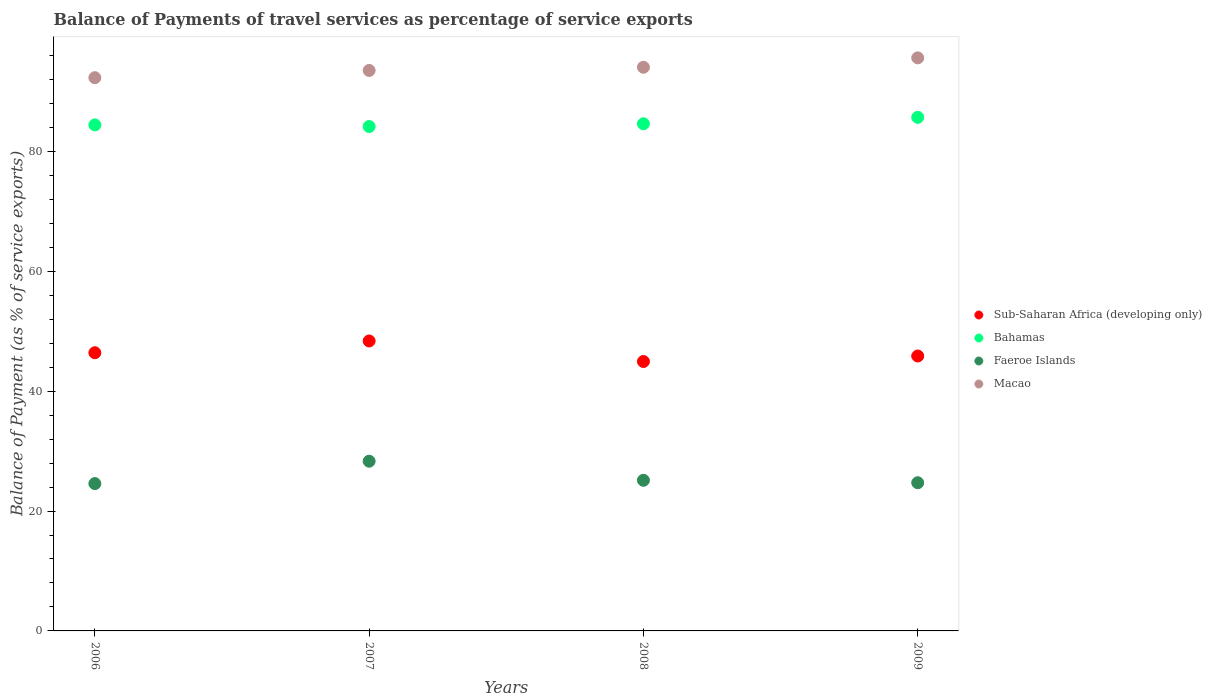Is the number of dotlines equal to the number of legend labels?
Keep it short and to the point. Yes. What is the balance of payments of travel services in Faeroe Islands in 2009?
Provide a succinct answer. 24.72. Across all years, what is the maximum balance of payments of travel services in Bahamas?
Your answer should be very brief. 85.68. Across all years, what is the minimum balance of payments of travel services in Bahamas?
Provide a succinct answer. 84.14. What is the total balance of payments of travel services in Sub-Saharan Africa (developing only) in the graph?
Your answer should be very brief. 185.58. What is the difference between the balance of payments of travel services in Bahamas in 2006 and that in 2007?
Make the answer very short. 0.27. What is the difference between the balance of payments of travel services in Faeroe Islands in 2006 and the balance of payments of travel services in Macao in 2008?
Offer a very short reply. -69.46. What is the average balance of payments of travel services in Macao per year?
Provide a succinct answer. 93.85. In the year 2008, what is the difference between the balance of payments of travel services in Sub-Saharan Africa (developing only) and balance of payments of travel services in Faeroe Islands?
Provide a succinct answer. 19.82. In how many years, is the balance of payments of travel services in Macao greater than 8 %?
Provide a short and direct response. 4. What is the ratio of the balance of payments of travel services in Sub-Saharan Africa (developing only) in 2006 to that in 2007?
Keep it short and to the point. 0.96. Is the difference between the balance of payments of travel services in Sub-Saharan Africa (developing only) in 2006 and 2007 greater than the difference between the balance of payments of travel services in Faeroe Islands in 2006 and 2007?
Make the answer very short. Yes. What is the difference between the highest and the second highest balance of payments of travel services in Sub-Saharan Africa (developing only)?
Provide a short and direct response. 1.97. What is the difference between the highest and the lowest balance of payments of travel services in Faeroe Islands?
Your response must be concise. 3.73. In how many years, is the balance of payments of travel services in Bahamas greater than the average balance of payments of travel services in Bahamas taken over all years?
Offer a very short reply. 1. Is the sum of the balance of payments of travel services in Sub-Saharan Africa (developing only) in 2007 and 2008 greater than the maximum balance of payments of travel services in Faeroe Islands across all years?
Give a very brief answer. Yes. Is it the case that in every year, the sum of the balance of payments of travel services in Macao and balance of payments of travel services in Faeroe Islands  is greater than the balance of payments of travel services in Bahamas?
Make the answer very short. Yes. Does the balance of payments of travel services in Macao monotonically increase over the years?
Give a very brief answer. Yes. Is the balance of payments of travel services in Bahamas strictly greater than the balance of payments of travel services in Sub-Saharan Africa (developing only) over the years?
Keep it short and to the point. Yes. Are the values on the major ticks of Y-axis written in scientific E-notation?
Your answer should be compact. No. Does the graph contain grids?
Offer a terse response. No. How many legend labels are there?
Make the answer very short. 4. How are the legend labels stacked?
Provide a short and direct response. Vertical. What is the title of the graph?
Give a very brief answer. Balance of Payments of travel services as percentage of service exports. Does "Spain" appear as one of the legend labels in the graph?
Your response must be concise. No. What is the label or title of the Y-axis?
Give a very brief answer. Balance of Payment (as % of service exports). What is the Balance of Payment (as % of service exports) in Sub-Saharan Africa (developing only) in 2006?
Provide a short and direct response. 46.4. What is the Balance of Payment (as % of service exports) in Bahamas in 2006?
Ensure brevity in your answer.  84.42. What is the Balance of Payment (as % of service exports) in Faeroe Islands in 2006?
Ensure brevity in your answer.  24.58. What is the Balance of Payment (as % of service exports) of Macao in 2006?
Offer a very short reply. 92.29. What is the Balance of Payment (as % of service exports) of Sub-Saharan Africa (developing only) in 2007?
Offer a terse response. 48.37. What is the Balance of Payment (as % of service exports) of Bahamas in 2007?
Offer a terse response. 84.14. What is the Balance of Payment (as % of service exports) in Faeroe Islands in 2007?
Your answer should be compact. 28.31. What is the Balance of Payment (as % of service exports) in Macao in 2007?
Your answer should be compact. 93.5. What is the Balance of Payment (as % of service exports) in Sub-Saharan Africa (developing only) in 2008?
Your answer should be compact. 44.94. What is the Balance of Payment (as % of service exports) of Bahamas in 2008?
Provide a short and direct response. 84.6. What is the Balance of Payment (as % of service exports) in Faeroe Islands in 2008?
Your answer should be very brief. 25.13. What is the Balance of Payment (as % of service exports) in Macao in 2008?
Your answer should be compact. 94.03. What is the Balance of Payment (as % of service exports) in Sub-Saharan Africa (developing only) in 2009?
Keep it short and to the point. 45.86. What is the Balance of Payment (as % of service exports) in Bahamas in 2009?
Ensure brevity in your answer.  85.68. What is the Balance of Payment (as % of service exports) in Faeroe Islands in 2009?
Your response must be concise. 24.72. What is the Balance of Payment (as % of service exports) of Macao in 2009?
Your response must be concise. 95.6. Across all years, what is the maximum Balance of Payment (as % of service exports) of Sub-Saharan Africa (developing only)?
Your response must be concise. 48.37. Across all years, what is the maximum Balance of Payment (as % of service exports) of Bahamas?
Your answer should be very brief. 85.68. Across all years, what is the maximum Balance of Payment (as % of service exports) in Faeroe Islands?
Offer a terse response. 28.31. Across all years, what is the maximum Balance of Payment (as % of service exports) of Macao?
Give a very brief answer. 95.6. Across all years, what is the minimum Balance of Payment (as % of service exports) in Sub-Saharan Africa (developing only)?
Offer a terse response. 44.94. Across all years, what is the minimum Balance of Payment (as % of service exports) of Bahamas?
Provide a succinct answer. 84.14. Across all years, what is the minimum Balance of Payment (as % of service exports) in Faeroe Islands?
Your answer should be very brief. 24.58. Across all years, what is the minimum Balance of Payment (as % of service exports) in Macao?
Give a very brief answer. 92.29. What is the total Balance of Payment (as % of service exports) of Sub-Saharan Africa (developing only) in the graph?
Your answer should be very brief. 185.58. What is the total Balance of Payment (as % of service exports) in Bahamas in the graph?
Your response must be concise. 338.84. What is the total Balance of Payment (as % of service exports) in Faeroe Islands in the graph?
Provide a succinct answer. 102.74. What is the total Balance of Payment (as % of service exports) in Macao in the graph?
Offer a very short reply. 375.42. What is the difference between the Balance of Payment (as % of service exports) in Sub-Saharan Africa (developing only) in 2006 and that in 2007?
Your response must be concise. -1.97. What is the difference between the Balance of Payment (as % of service exports) of Bahamas in 2006 and that in 2007?
Provide a succinct answer. 0.27. What is the difference between the Balance of Payment (as % of service exports) in Faeroe Islands in 2006 and that in 2007?
Your answer should be very brief. -3.73. What is the difference between the Balance of Payment (as % of service exports) of Macao in 2006 and that in 2007?
Your answer should be very brief. -1.21. What is the difference between the Balance of Payment (as % of service exports) in Sub-Saharan Africa (developing only) in 2006 and that in 2008?
Offer a terse response. 1.46. What is the difference between the Balance of Payment (as % of service exports) in Bahamas in 2006 and that in 2008?
Your answer should be very brief. -0.19. What is the difference between the Balance of Payment (as % of service exports) in Faeroe Islands in 2006 and that in 2008?
Provide a short and direct response. -0.55. What is the difference between the Balance of Payment (as % of service exports) in Macao in 2006 and that in 2008?
Offer a very short reply. -1.74. What is the difference between the Balance of Payment (as % of service exports) in Sub-Saharan Africa (developing only) in 2006 and that in 2009?
Make the answer very short. 0.54. What is the difference between the Balance of Payment (as % of service exports) of Bahamas in 2006 and that in 2009?
Your response must be concise. -1.26. What is the difference between the Balance of Payment (as % of service exports) of Faeroe Islands in 2006 and that in 2009?
Offer a terse response. -0.14. What is the difference between the Balance of Payment (as % of service exports) in Macao in 2006 and that in 2009?
Offer a terse response. -3.31. What is the difference between the Balance of Payment (as % of service exports) of Sub-Saharan Africa (developing only) in 2007 and that in 2008?
Your answer should be very brief. 3.43. What is the difference between the Balance of Payment (as % of service exports) of Bahamas in 2007 and that in 2008?
Offer a terse response. -0.46. What is the difference between the Balance of Payment (as % of service exports) of Faeroe Islands in 2007 and that in 2008?
Your answer should be compact. 3.18. What is the difference between the Balance of Payment (as % of service exports) in Macao in 2007 and that in 2008?
Give a very brief answer. -0.53. What is the difference between the Balance of Payment (as % of service exports) of Sub-Saharan Africa (developing only) in 2007 and that in 2009?
Keep it short and to the point. 2.51. What is the difference between the Balance of Payment (as % of service exports) of Bahamas in 2007 and that in 2009?
Your response must be concise. -1.53. What is the difference between the Balance of Payment (as % of service exports) in Faeroe Islands in 2007 and that in 2009?
Your answer should be very brief. 3.59. What is the difference between the Balance of Payment (as % of service exports) of Macao in 2007 and that in 2009?
Give a very brief answer. -2.1. What is the difference between the Balance of Payment (as % of service exports) of Sub-Saharan Africa (developing only) in 2008 and that in 2009?
Your response must be concise. -0.92. What is the difference between the Balance of Payment (as % of service exports) in Bahamas in 2008 and that in 2009?
Make the answer very short. -1.08. What is the difference between the Balance of Payment (as % of service exports) in Faeroe Islands in 2008 and that in 2009?
Your answer should be very brief. 0.41. What is the difference between the Balance of Payment (as % of service exports) of Macao in 2008 and that in 2009?
Ensure brevity in your answer.  -1.56. What is the difference between the Balance of Payment (as % of service exports) in Sub-Saharan Africa (developing only) in 2006 and the Balance of Payment (as % of service exports) in Bahamas in 2007?
Provide a succinct answer. -37.74. What is the difference between the Balance of Payment (as % of service exports) in Sub-Saharan Africa (developing only) in 2006 and the Balance of Payment (as % of service exports) in Faeroe Islands in 2007?
Offer a very short reply. 18.09. What is the difference between the Balance of Payment (as % of service exports) of Sub-Saharan Africa (developing only) in 2006 and the Balance of Payment (as % of service exports) of Macao in 2007?
Offer a very short reply. -47.1. What is the difference between the Balance of Payment (as % of service exports) of Bahamas in 2006 and the Balance of Payment (as % of service exports) of Faeroe Islands in 2007?
Keep it short and to the point. 56.11. What is the difference between the Balance of Payment (as % of service exports) in Bahamas in 2006 and the Balance of Payment (as % of service exports) in Macao in 2007?
Make the answer very short. -9.08. What is the difference between the Balance of Payment (as % of service exports) of Faeroe Islands in 2006 and the Balance of Payment (as % of service exports) of Macao in 2007?
Your response must be concise. -68.92. What is the difference between the Balance of Payment (as % of service exports) in Sub-Saharan Africa (developing only) in 2006 and the Balance of Payment (as % of service exports) in Bahamas in 2008?
Provide a succinct answer. -38.2. What is the difference between the Balance of Payment (as % of service exports) in Sub-Saharan Africa (developing only) in 2006 and the Balance of Payment (as % of service exports) in Faeroe Islands in 2008?
Make the answer very short. 21.27. What is the difference between the Balance of Payment (as % of service exports) in Sub-Saharan Africa (developing only) in 2006 and the Balance of Payment (as % of service exports) in Macao in 2008?
Ensure brevity in your answer.  -47.63. What is the difference between the Balance of Payment (as % of service exports) in Bahamas in 2006 and the Balance of Payment (as % of service exports) in Faeroe Islands in 2008?
Give a very brief answer. 59.29. What is the difference between the Balance of Payment (as % of service exports) in Bahamas in 2006 and the Balance of Payment (as % of service exports) in Macao in 2008?
Offer a terse response. -9.62. What is the difference between the Balance of Payment (as % of service exports) of Faeroe Islands in 2006 and the Balance of Payment (as % of service exports) of Macao in 2008?
Keep it short and to the point. -69.46. What is the difference between the Balance of Payment (as % of service exports) of Sub-Saharan Africa (developing only) in 2006 and the Balance of Payment (as % of service exports) of Bahamas in 2009?
Offer a very short reply. -39.28. What is the difference between the Balance of Payment (as % of service exports) in Sub-Saharan Africa (developing only) in 2006 and the Balance of Payment (as % of service exports) in Faeroe Islands in 2009?
Offer a terse response. 21.68. What is the difference between the Balance of Payment (as % of service exports) in Sub-Saharan Africa (developing only) in 2006 and the Balance of Payment (as % of service exports) in Macao in 2009?
Provide a succinct answer. -49.19. What is the difference between the Balance of Payment (as % of service exports) of Bahamas in 2006 and the Balance of Payment (as % of service exports) of Faeroe Islands in 2009?
Keep it short and to the point. 59.7. What is the difference between the Balance of Payment (as % of service exports) in Bahamas in 2006 and the Balance of Payment (as % of service exports) in Macao in 2009?
Give a very brief answer. -11.18. What is the difference between the Balance of Payment (as % of service exports) of Faeroe Islands in 2006 and the Balance of Payment (as % of service exports) of Macao in 2009?
Make the answer very short. -71.02. What is the difference between the Balance of Payment (as % of service exports) in Sub-Saharan Africa (developing only) in 2007 and the Balance of Payment (as % of service exports) in Bahamas in 2008?
Provide a short and direct response. -36.23. What is the difference between the Balance of Payment (as % of service exports) in Sub-Saharan Africa (developing only) in 2007 and the Balance of Payment (as % of service exports) in Faeroe Islands in 2008?
Offer a very short reply. 23.24. What is the difference between the Balance of Payment (as % of service exports) of Sub-Saharan Africa (developing only) in 2007 and the Balance of Payment (as % of service exports) of Macao in 2008?
Make the answer very short. -45.66. What is the difference between the Balance of Payment (as % of service exports) in Bahamas in 2007 and the Balance of Payment (as % of service exports) in Faeroe Islands in 2008?
Provide a short and direct response. 59.02. What is the difference between the Balance of Payment (as % of service exports) of Bahamas in 2007 and the Balance of Payment (as % of service exports) of Macao in 2008?
Give a very brief answer. -9.89. What is the difference between the Balance of Payment (as % of service exports) in Faeroe Islands in 2007 and the Balance of Payment (as % of service exports) in Macao in 2008?
Your answer should be very brief. -65.72. What is the difference between the Balance of Payment (as % of service exports) in Sub-Saharan Africa (developing only) in 2007 and the Balance of Payment (as % of service exports) in Bahamas in 2009?
Your answer should be compact. -37.31. What is the difference between the Balance of Payment (as % of service exports) in Sub-Saharan Africa (developing only) in 2007 and the Balance of Payment (as % of service exports) in Faeroe Islands in 2009?
Your answer should be compact. 23.65. What is the difference between the Balance of Payment (as % of service exports) in Sub-Saharan Africa (developing only) in 2007 and the Balance of Payment (as % of service exports) in Macao in 2009?
Your response must be concise. -47.23. What is the difference between the Balance of Payment (as % of service exports) of Bahamas in 2007 and the Balance of Payment (as % of service exports) of Faeroe Islands in 2009?
Ensure brevity in your answer.  59.43. What is the difference between the Balance of Payment (as % of service exports) in Bahamas in 2007 and the Balance of Payment (as % of service exports) in Macao in 2009?
Your response must be concise. -11.45. What is the difference between the Balance of Payment (as % of service exports) in Faeroe Islands in 2007 and the Balance of Payment (as % of service exports) in Macao in 2009?
Keep it short and to the point. -67.29. What is the difference between the Balance of Payment (as % of service exports) in Sub-Saharan Africa (developing only) in 2008 and the Balance of Payment (as % of service exports) in Bahamas in 2009?
Provide a succinct answer. -40.73. What is the difference between the Balance of Payment (as % of service exports) of Sub-Saharan Africa (developing only) in 2008 and the Balance of Payment (as % of service exports) of Faeroe Islands in 2009?
Offer a terse response. 20.22. What is the difference between the Balance of Payment (as % of service exports) in Sub-Saharan Africa (developing only) in 2008 and the Balance of Payment (as % of service exports) in Macao in 2009?
Ensure brevity in your answer.  -50.65. What is the difference between the Balance of Payment (as % of service exports) in Bahamas in 2008 and the Balance of Payment (as % of service exports) in Faeroe Islands in 2009?
Ensure brevity in your answer.  59.88. What is the difference between the Balance of Payment (as % of service exports) of Bahamas in 2008 and the Balance of Payment (as % of service exports) of Macao in 2009?
Provide a short and direct response. -10.99. What is the difference between the Balance of Payment (as % of service exports) in Faeroe Islands in 2008 and the Balance of Payment (as % of service exports) in Macao in 2009?
Offer a very short reply. -70.47. What is the average Balance of Payment (as % of service exports) in Sub-Saharan Africa (developing only) per year?
Make the answer very short. 46.4. What is the average Balance of Payment (as % of service exports) of Bahamas per year?
Your response must be concise. 84.71. What is the average Balance of Payment (as % of service exports) in Faeroe Islands per year?
Provide a succinct answer. 25.68. What is the average Balance of Payment (as % of service exports) of Macao per year?
Ensure brevity in your answer.  93.85. In the year 2006, what is the difference between the Balance of Payment (as % of service exports) in Sub-Saharan Africa (developing only) and Balance of Payment (as % of service exports) in Bahamas?
Make the answer very short. -38.01. In the year 2006, what is the difference between the Balance of Payment (as % of service exports) of Sub-Saharan Africa (developing only) and Balance of Payment (as % of service exports) of Faeroe Islands?
Offer a very short reply. 21.82. In the year 2006, what is the difference between the Balance of Payment (as % of service exports) in Sub-Saharan Africa (developing only) and Balance of Payment (as % of service exports) in Macao?
Keep it short and to the point. -45.89. In the year 2006, what is the difference between the Balance of Payment (as % of service exports) in Bahamas and Balance of Payment (as % of service exports) in Faeroe Islands?
Offer a terse response. 59.84. In the year 2006, what is the difference between the Balance of Payment (as % of service exports) in Bahamas and Balance of Payment (as % of service exports) in Macao?
Your answer should be very brief. -7.87. In the year 2006, what is the difference between the Balance of Payment (as % of service exports) in Faeroe Islands and Balance of Payment (as % of service exports) in Macao?
Your answer should be compact. -67.71. In the year 2007, what is the difference between the Balance of Payment (as % of service exports) in Sub-Saharan Africa (developing only) and Balance of Payment (as % of service exports) in Bahamas?
Ensure brevity in your answer.  -35.77. In the year 2007, what is the difference between the Balance of Payment (as % of service exports) of Sub-Saharan Africa (developing only) and Balance of Payment (as % of service exports) of Faeroe Islands?
Provide a short and direct response. 20.06. In the year 2007, what is the difference between the Balance of Payment (as % of service exports) of Sub-Saharan Africa (developing only) and Balance of Payment (as % of service exports) of Macao?
Provide a succinct answer. -45.13. In the year 2007, what is the difference between the Balance of Payment (as % of service exports) of Bahamas and Balance of Payment (as % of service exports) of Faeroe Islands?
Your answer should be very brief. 55.83. In the year 2007, what is the difference between the Balance of Payment (as % of service exports) of Bahamas and Balance of Payment (as % of service exports) of Macao?
Provide a succinct answer. -9.35. In the year 2007, what is the difference between the Balance of Payment (as % of service exports) of Faeroe Islands and Balance of Payment (as % of service exports) of Macao?
Your response must be concise. -65.19. In the year 2008, what is the difference between the Balance of Payment (as % of service exports) in Sub-Saharan Africa (developing only) and Balance of Payment (as % of service exports) in Bahamas?
Your answer should be very brief. -39.66. In the year 2008, what is the difference between the Balance of Payment (as % of service exports) of Sub-Saharan Africa (developing only) and Balance of Payment (as % of service exports) of Faeroe Islands?
Ensure brevity in your answer.  19.82. In the year 2008, what is the difference between the Balance of Payment (as % of service exports) in Sub-Saharan Africa (developing only) and Balance of Payment (as % of service exports) in Macao?
Your answer should be very brief. -49.09. In the year 2008, what is the difference between the Balance of Payment (as % of service exports) in Bahamas and Balance of Payment (as % of service exports) in Faeroe Islands?
Make the answer very short. 59.47. In the year 2008, what is the difference between the Balance of Payment (as % of service exports) in Bahamas and Balance of Payment (as % of service exports) in Macao?
Keep it short and to the point. -9.43. In the year 2008, what is the difference between the Balance of Payment (as % of service exports) of Faeroe Islands and Balance of Payment (as % of service exports) of Macao?
Give a very brief answer. -68.91. In the year 2009, what is the difference between the Balance of Payment (as % of service exports) of Sub-Saharan Africa (developing only) and Balance of Payment (as % of service exports) of Bahamas?
Provide a succinct answer. -39.82. In the year 2009, what is the difference between the Balance of Payment (as % of service exports) in Sub-Saharan Africa (developing only) and Balance of Payment (as % of service exports) in Faeroe Islands?
Make the answer very short. 21.14. In the year 2009, what is the difference between the Balance of Payment (as % of service exports) in Sub-Saharan Africa (developing only) and Balance of Payment (as % of service exports) in Macao?
Offer a very short reply. -49.73. In the year 2009, what is the difference between the Balance of Payment (as % of service exports) of Bahamas and Balance of Payment (as % of service exports) of Faeroe Islands?
Make the answer very short. 60.96. In the year 2009, what is the difference between the Balance of Payment (as % of service exports) of Bahamas and Balance of Payment (as % of service exports) of Macao?
Make the answer very short. -9.92. In the year 2009, what is the difference between the Balance of Payment (as % of service exports) in Faeroe Islands and Balance of Payment (as % of service exports) in Macao?
Your response must be concise. -70.88. What is the ratio of the Balance of Payment (as % of service exports) of Sub-Saharan Africa (developing only) in 2006 to that in 2007?
Give a very brief answer. 0.96. What is the ratio of the Balance of Payment (as % of service exports) of Faeroe Islands in 2006 to that in 2007?
Provide a short and direct response. 0.87. What is the ratio of the Balance of Payment (as % of service exports) in Macao in 2006 to that in 2007?
Provide a short and direct response. 0.99. What is the ratio of the Balance of Payment (as % of service exports) in Sub-Saharan Africa (developing only) in 2006 to that in 2008?
Provide a short and direct response. 1.03. What is the ratio of the Balance of Payment (as % of service exports) in Faeroe Islands in 2006 to that in 2008?
Keep it short and to the point. 0.98. What is the ratio of the Balance of Payment (as % of service exports) of Macao in 2006 to that in 2008?
Give a very brief answer. 0.98. What is the ratio of the Balance of Payment (as % of service exports) of Sub-Saharan Africa (developing only) in 2006 to that in 2009?
Provide a succinct answer. 1.01. What is the ratio of the Balance of Payment (as % of service exports) of Bahamas in 2006 to that in 2009?
Ensure brevity in your answer.  0.99. What is the ratio of the Balance of Payment (as % of service exports) of Faeroe Islands in 2006 to that in 2009?
Give a very brief answer. 0.99. What is the ratio of the Balance of Payment (as % of service exports) in Macao in 2006 to that in 2009?
Make the answer very short. 0.97. What is the ratio of the Balance of Payment (as % of service exports) of Sub-Saharan Africa (developing only) in 2007 to that in 2008?
Make the answer very short. 1.08. What is the ratio of the Balance of Payment (as % of service exports) in Bahamas in 2007 to that in 2008?
Give a very brief answer. 0.99. What is the ratio of the Balance of Payment (as % of service exports) of Faeroe Islands in 2007 to that in 2008?
Keep it short and to the point. 1.13. What is the ratio of the Balance of Payment (as % of service exports) in Macao in 2007 to that in 2008?
Ensure brevity in your answer.  0.99. What is the ratio of the Balance of Payment (as % of service exports) of Sub-Saharan Africa (developing only) in 2007 to that in 2009?
Make the answer very short. 1.05. What is the ratio of the Balance of Payment (as % of service exports) in Bahamas in 2007 to that in 2009?
Provide a short and direct response. 0.98. What is the ratio of the Balance of Payment (as % of service exports) of Faeroe Islands in 2007 to that in 2009?
Make the answer very short. 1.15. What is the ratio of the Balance of Payment (as % of service exports) of Sub-Saharan Africa (developing only) in 2008 to that in 2009?
Give a very brief answer. 0.98. What is the ratio of the Balance of Payment (as % of service exports) of Bahamas in 2008 to that in 2009?
Make the answer very short. 0.99. What is the ratio of the Balance of Payment (as % of service exports) in Faeroe Islands in 2008 to that in 2009?
Make the answer very short. 1.02. What is the ratio of the Balance of Payment (as % of service exports) in Macao in 2008 to that in 2009?
Provide a succinct answer. 0.98. What is the difference between the highest and the second highest Balance of Payment (as % of service exports) in Sub-Saharan Africa (developing only)?
Make the answer very short. 1.97. What is the difference between the highest and the second highest Balance of Payment (as % of service exports) of Bahamas?
Provide a succinct answer. 1.08. What is the difference between the highest and the second highest Balance of Payment (as % of service exports) in Faeroe Islands?
Offer a very short reply. 3.18. What is the difference between the highest and the second highest Balance of Payment (as % of service exports) in Macao?
Make the answer very short. 1.56. What is the difference between the highest and the lowest Balance of Payment (as % of service exports) in Sub-Saharan Africa (developing only)?
Offer a very short reply. 3.43. What is the difference between the highest and the lowest Balance of Payment (as % of service exports) in Bahamas?
Make the answer very short. 1.53. What is the difference between the highest and the lowest Balance of Payment (as % of service exports) in Faeroe Islands?
Provide a short and direct response. 3.73. What is the difference between the highest and the lowest Balance of Payment (as % of service exports) of Macao?
Your answer should be compact. 3.31. 